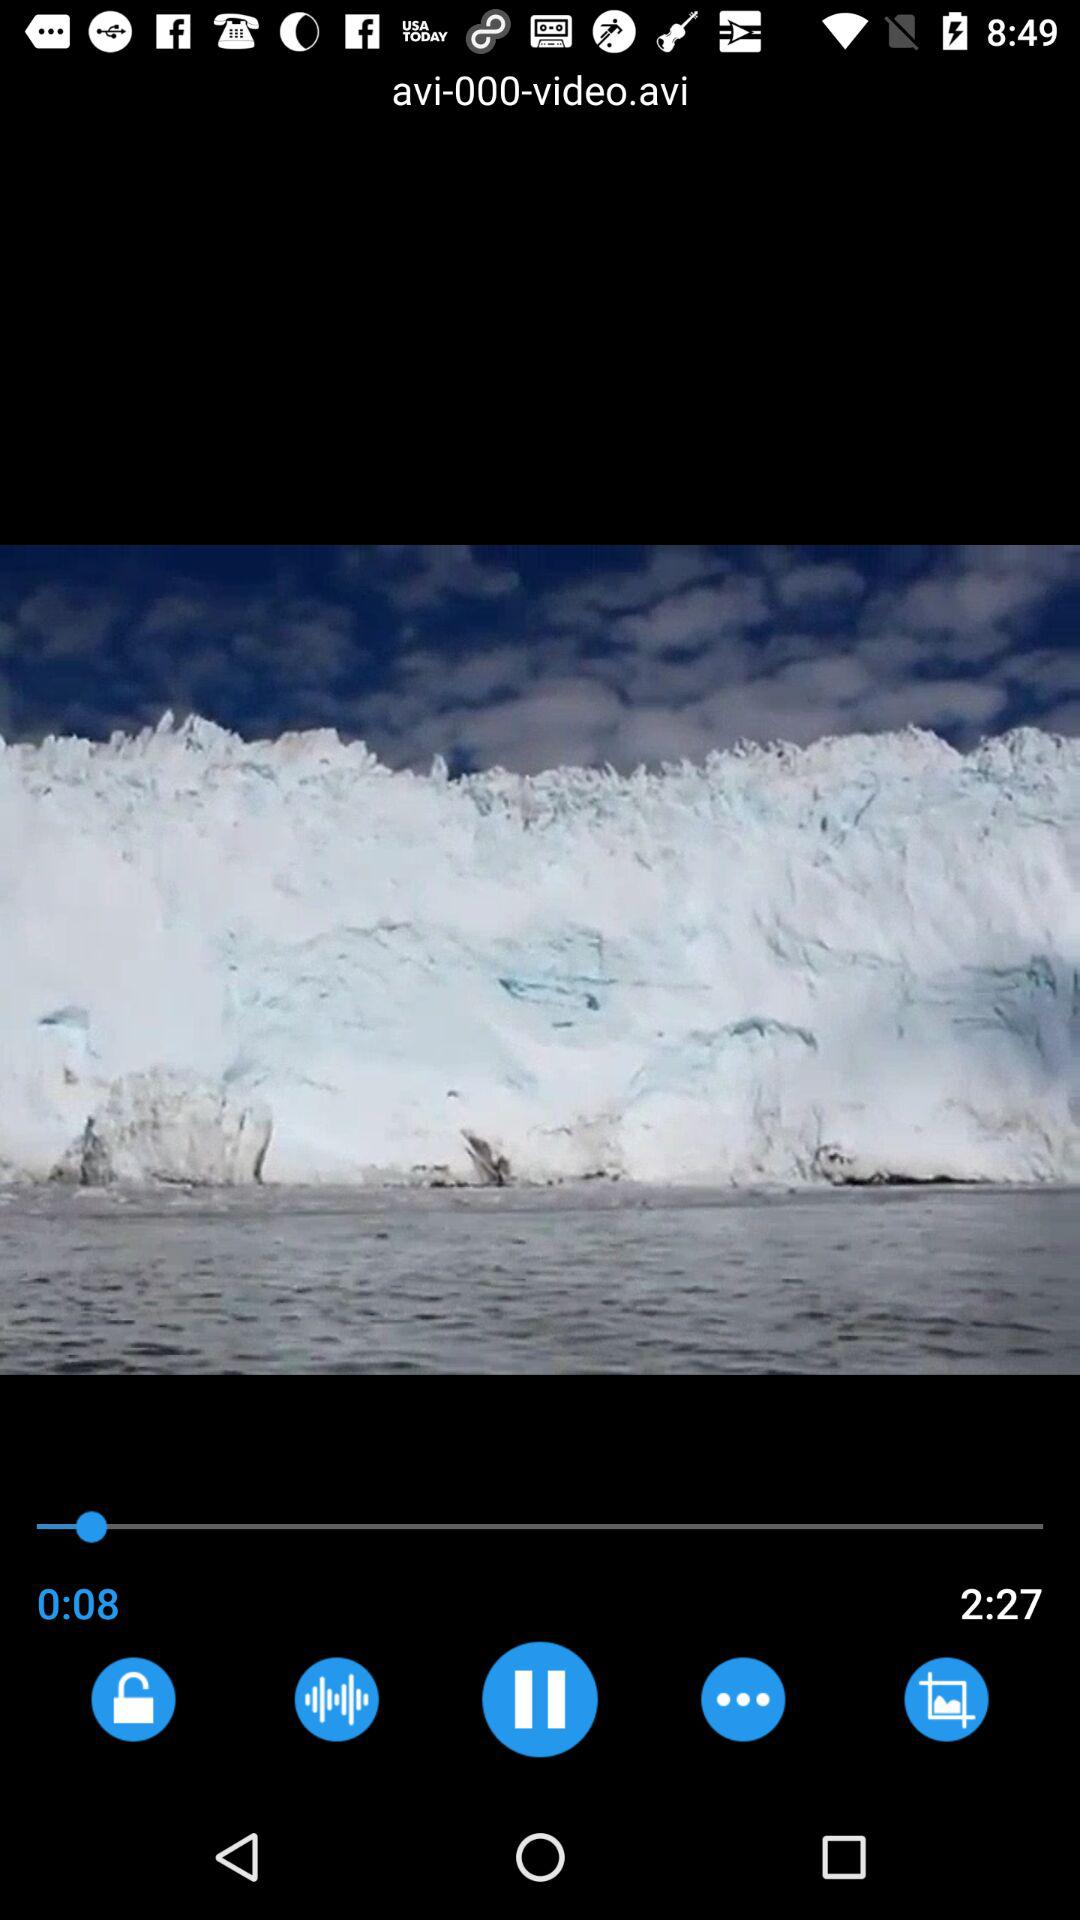What is the duration of the video? The duration is 2 minutes and 27 seconds. 